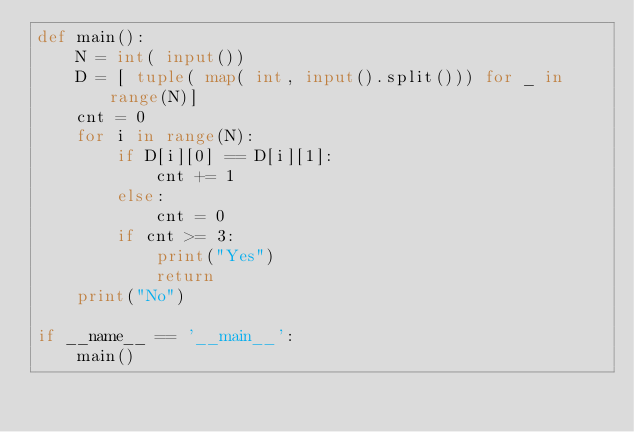Convert code to text. <code><loc_0><loc_0><loc_500><loc_500><_Python_>def main():
    N = int( input())
    D = [ tuple( map( int, input().split())) for _ in range(N)]
    cnt = 0
    for i in range(N):
        if D[i][0] == D[i][1]:
            cnt += 1
        else:
            cnt = 0
        if cnt >= 3:
            print("Yes")
            return
    print("No")
        
if __name__ == '__main__':
    main()
</code> 